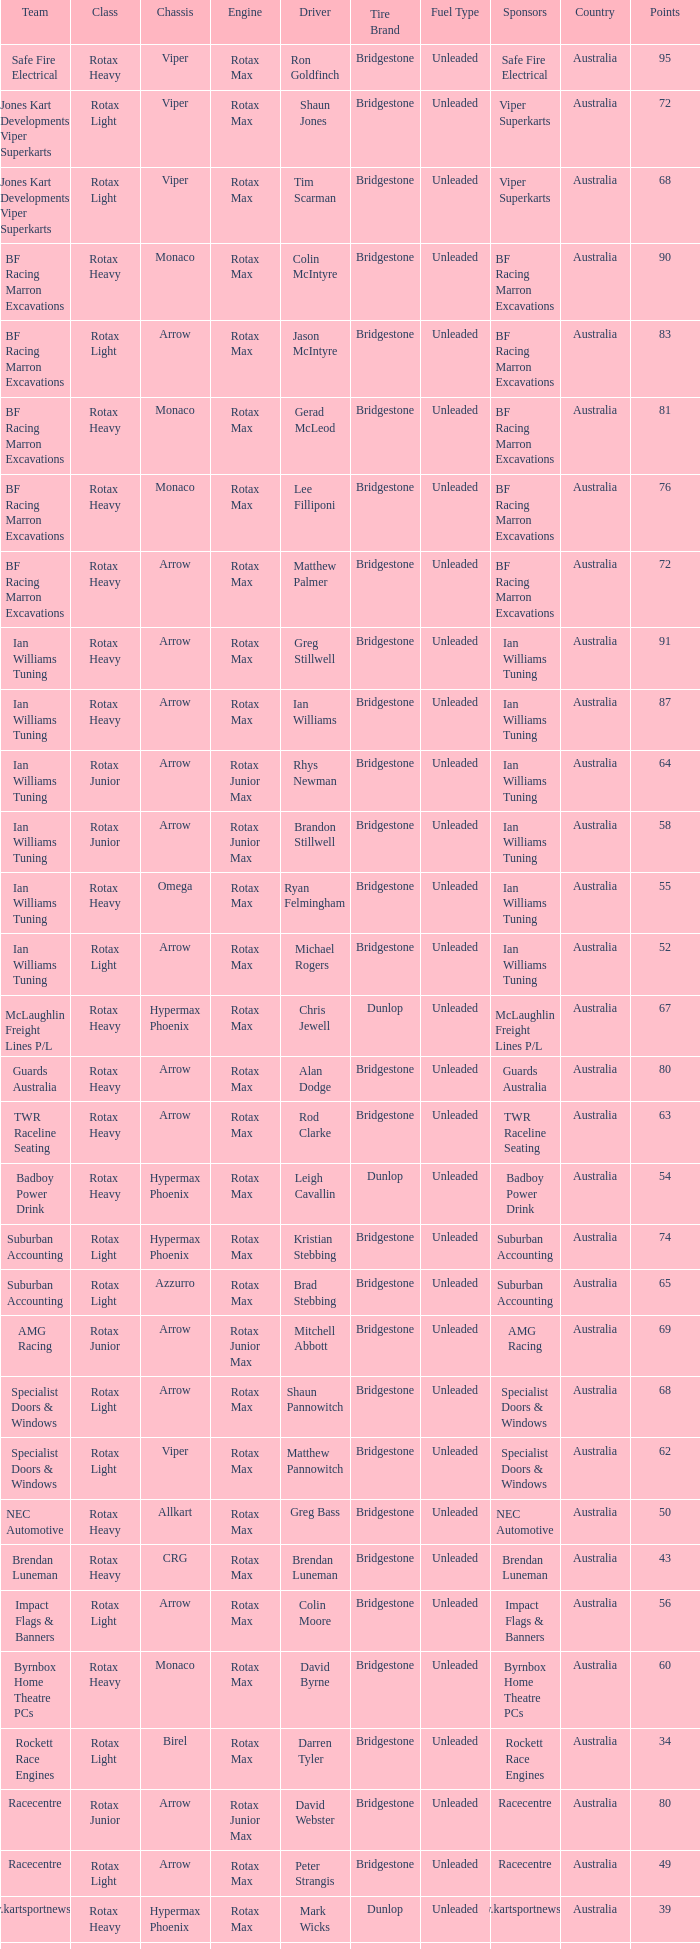What is the name of the team whose class is Rotax Light? Jones Kart Developments Viper Superkarts, Jones Kart Developments Viper Superkarts, BF Racing Marron Excavations, Ian Williams Tuning, Suburban Accounting, Suburban Accounting, Specialist Doors & Windows, Specialist Doors & Windows, Impact Flags & Banners, Rockett Race Engines, Racecentre, Doug Savage. 